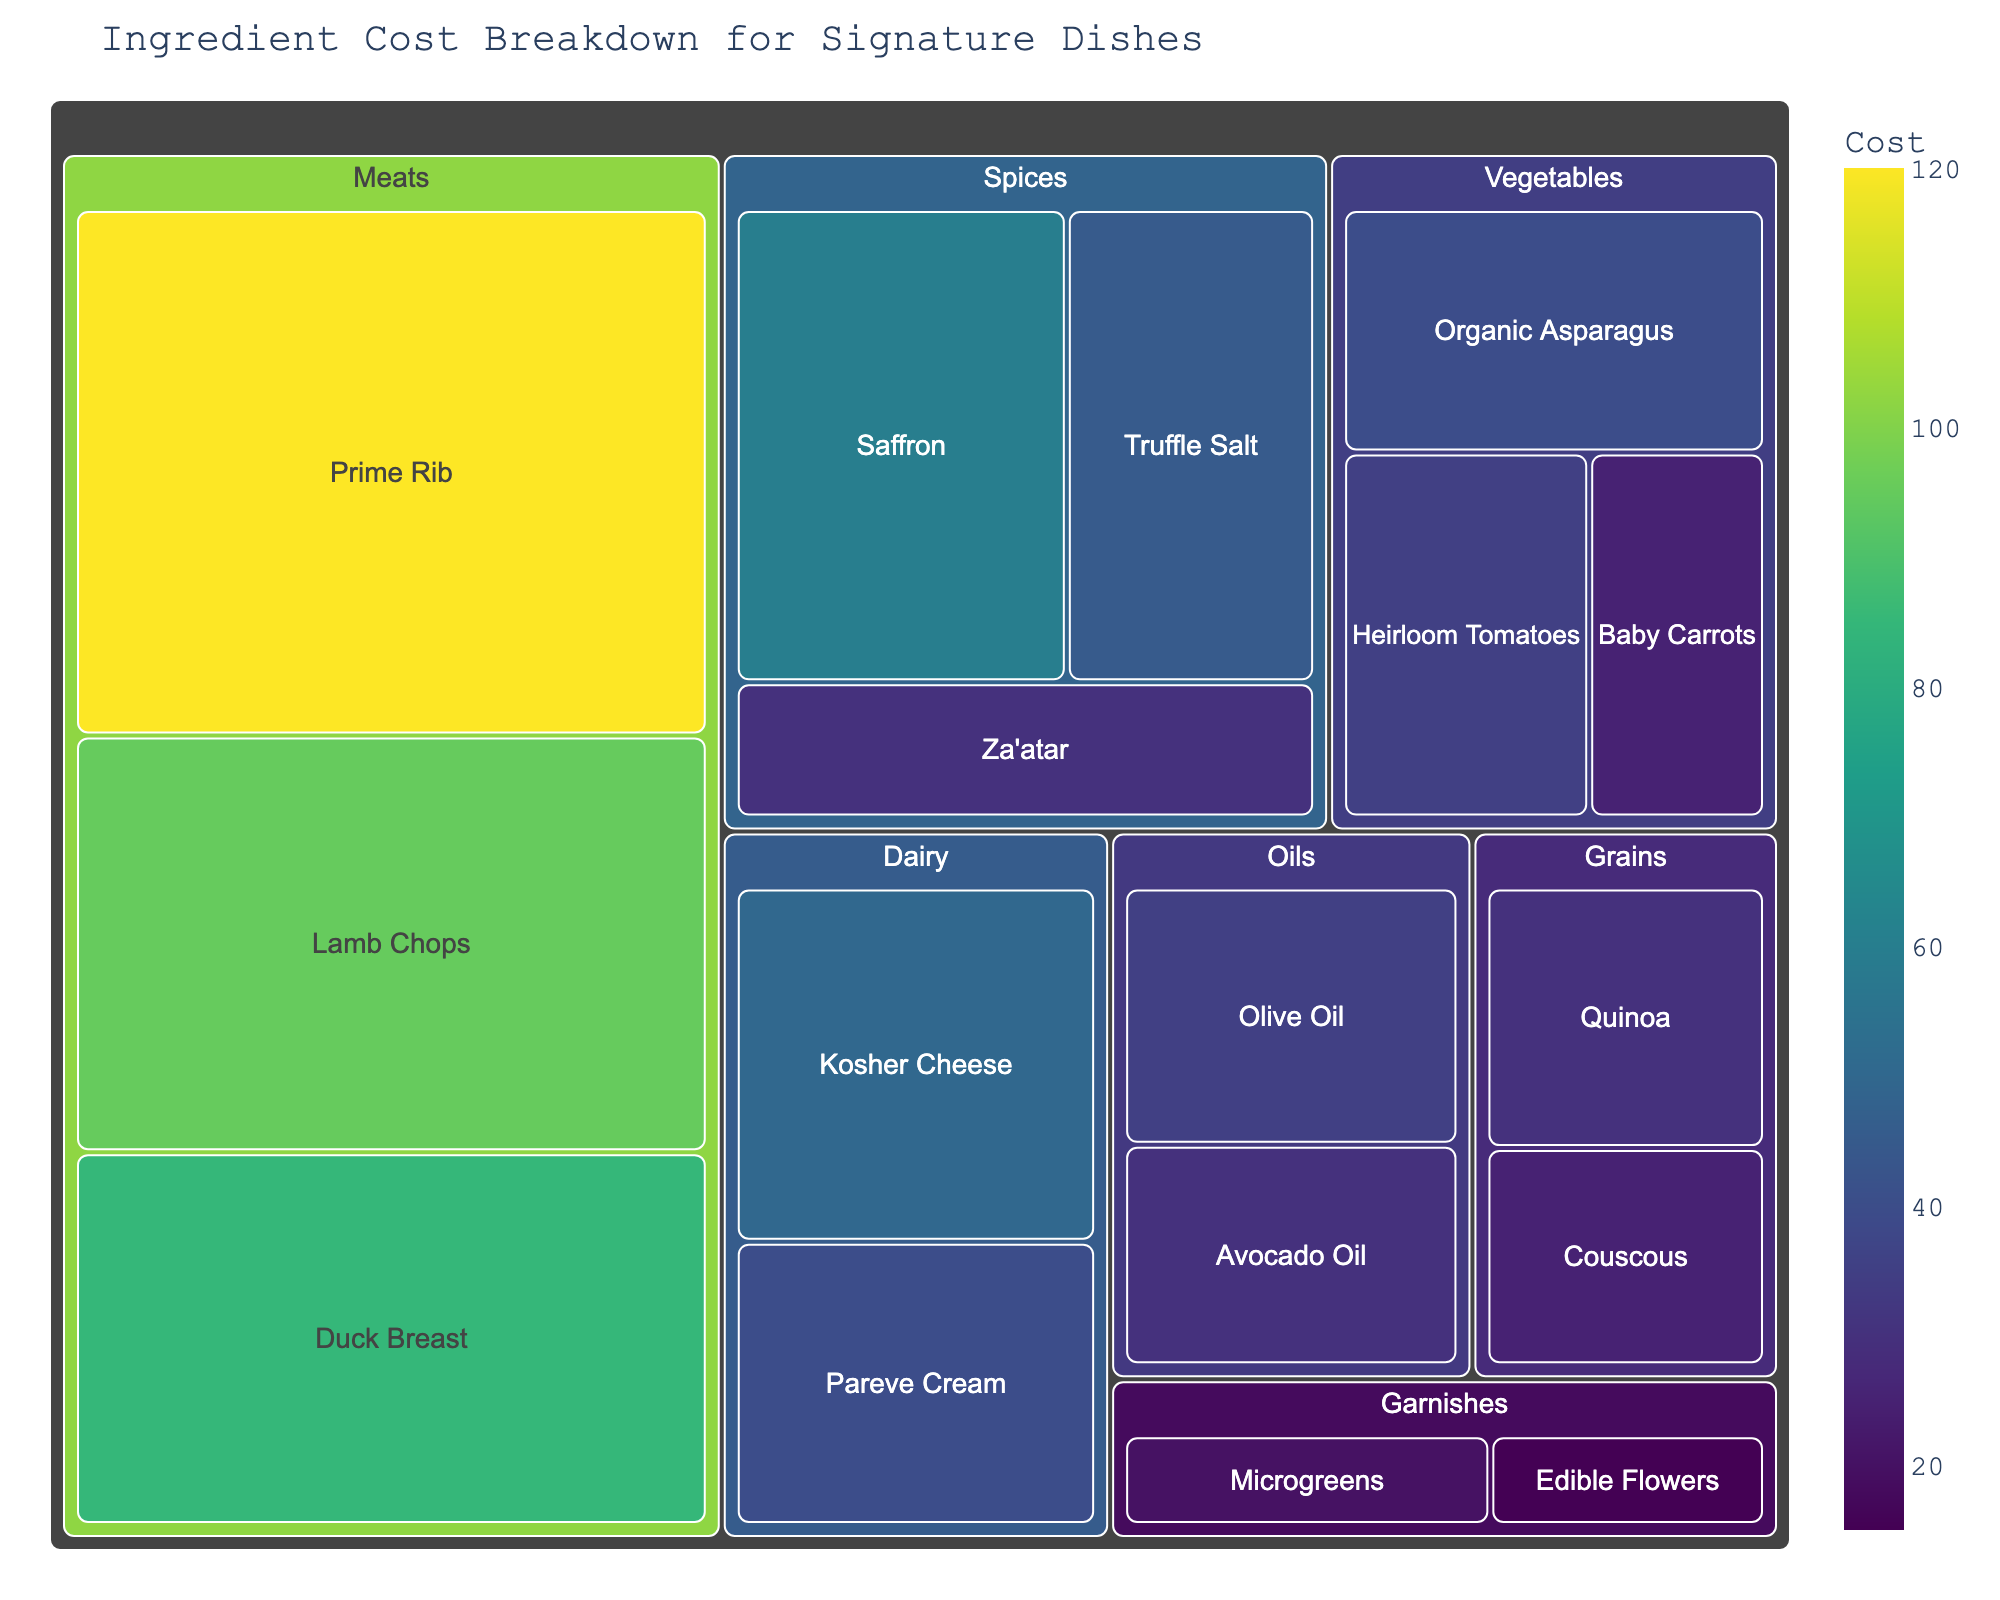What's the title of the treemap? The title is displayed at the top of the figure. It provides a brief summary of what the figure represents.
Answer: Ingredient Cost Breakdown for Signature Dishes Which category has the highest cost item? The cost values and their categories are visually represented in the treemap. The largest cell or the cell with the highest value indicates the highest cost item.
Answer: Meats What is the total cost for all Meat subcategories? Sum the cost values for the subcategories under the Meats category: Prime Rib (120), Lamb Chops (95), Duck Breast (85). 120 + 95 + 85 = 300.
Answer: $300 Between 'Saffron' and 'Truffle Salt', which spice is more expensive? Compare the cost values of the two subcategories under the Spices category.
Answer: Saffron What is the difference in cost between the most expensive and the least expensive subcategory in Vegetables? Identify the highest and lowest cost items under Vegetables: Organic Asparagus (40) and Baby Carrots (25). Subtract the smallest cost from the largest cost: 40 - 25 = 15.
Answer: $15 Which subcategory in Oils is more expensive? Compare the costs under the Oils category, which includes Olive Oil (35) and Avocado Oil (30).
Answer: Olive Oil How many subcategories are there in the Dairy category? Count the number of subcategories within the Dairy category.
Answer: 2 What is the combined cost of all the subcategories in the Grains category? Sum the cost values for the subcategories under the Grains category: Quinoa (30) and Couscous (25). 30 + 25 = 55.
Answer: $55 Which has a higher total cost, Spices or Garnishes? Calculate the total cost for each category: Spices (Saffron - 60, Truffle Salt - 45, Za'atar - 30) = 135 and Garnishes (Microgreens - 20, Edible Flowers - 15) = 35. Compare the two totals: 135 > 35.
Answer: Spices Which Dairy subcategory is less expensive? Compare the costs of the subcategories within the Dairy category, Kosher Cheese (50) and Pareve Cream (40).
Answer: Pareve Cream 